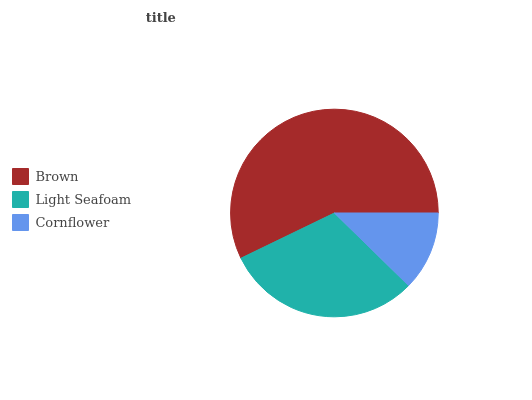Is Cornflower the minimum?
Answer yes or no. Yes. Is Brown the maximum?
Answer yes or no. Yes. Is Light Seafoam the minimum?
Answer yes or no. No. Is Light Seafoam the maximum?
Answer yes or no. No. Is Brown greater than Light Seafoam?
Answer yes or no. Yes. Is Light Seafoam less than Brown?
Answer yes or no. Yes. Is Light Seafoam greater than Brown?
Answer yes or no. No. Is Brown less than Light Seafoam?
Answer yes or no. No. Is Light Seafoam the high median?
Answer yes or no. Yes. Is Light Seafoam the low median?
Answer yes or no. Yes. Is Cornflower the high median?
Answer yes or no. No. Is Brown the low median?
Answer yes or no. No. 